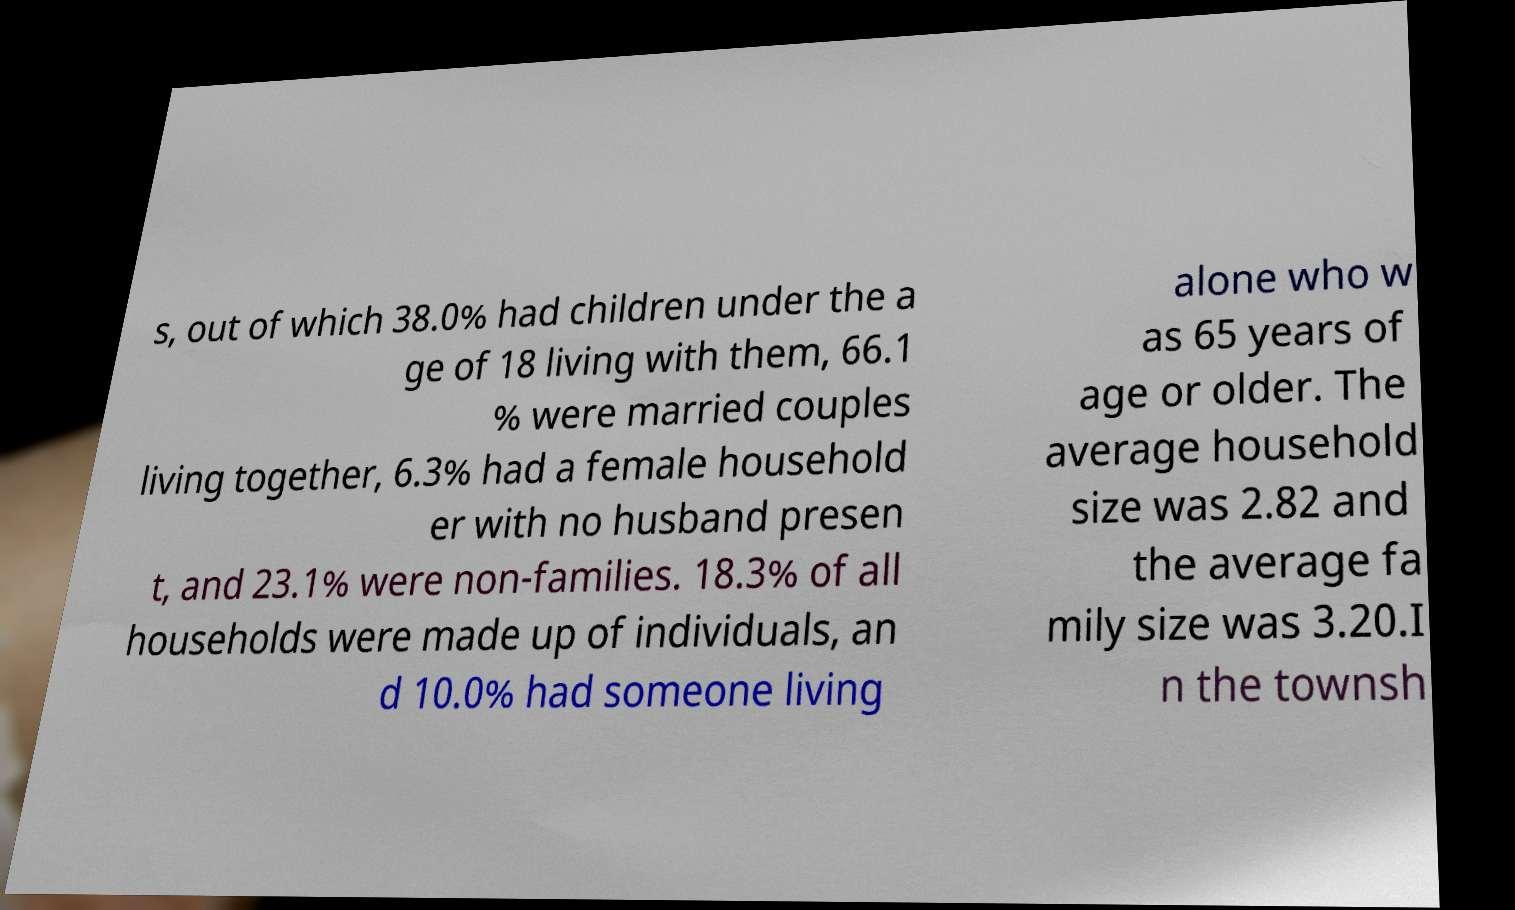For documentation purposes, I need the text within this image transcribed. Could you provide that? s, out of which 38.0% had children under the a ge of 18 living with them, 66.1 % were married couples living together, 6.3% had a female household er with no husband presen t, and 23.1% were non-families. 18.3% of all households were made up of individuals, an d 10.0% had someone living alone who w as 65 years of age or older. The average household size was 2.82 and the average fa mily size was 3.20.I n the townsh 